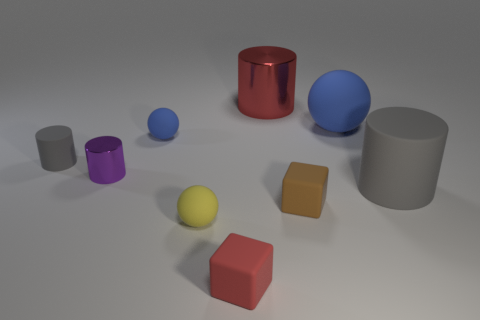Subtract all yellow blocks. Subtract all blue cylinders. How many blocks are left? 2 Add 1 brown things. How many objects exist? 10 Subtract all cylinders. How many objects are left? 5 Subtract 0 yellow cylinders. How many objects are left? 9 Subtract all small gray cylinders. Subtract all purple rubber spheres. How many objects are left? 8 Add 6 tiny red matte blocks. How many tiny red matte blocks are left? 7 Add 1 large purple rubber balls. How many large purple rubber balls exist? 1 